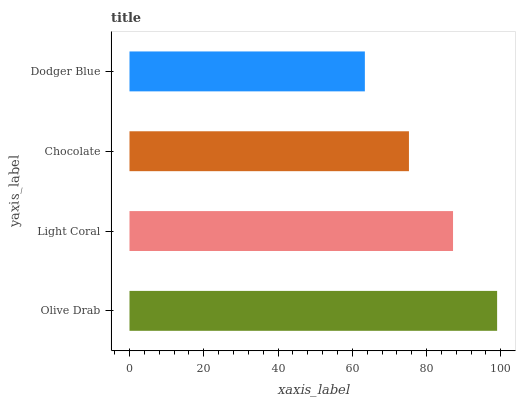Is Dodger Blue the minimum?
Answer yes or no. Yes. Is Olive Drab the maximum?
Answer yes or no. Yes. Is Light Coral the minimum?
Answer yes or no. No. Is Light Coral the maximum?
Answer yes or no. No. Is Olive Drab greater than Light Coral?
Answer yes or no. Yes. Is Light Coral less than Olive Drab?
Answer yes or no. Yes. Is Light Coral greater than Olive Drab?
Answer yes or no. No. Is Olive Drab less than Light Coral?
Answer yes or no. No. Is Light Coral the high median?
Answer yes or no. Yes. Is Chocolate the low median?
Answer yes or no. Yes. Is Dodger Blue the high median?
Answer yes or no. No. Is Dodger Blue the low median?
Answer yes or no. No. 